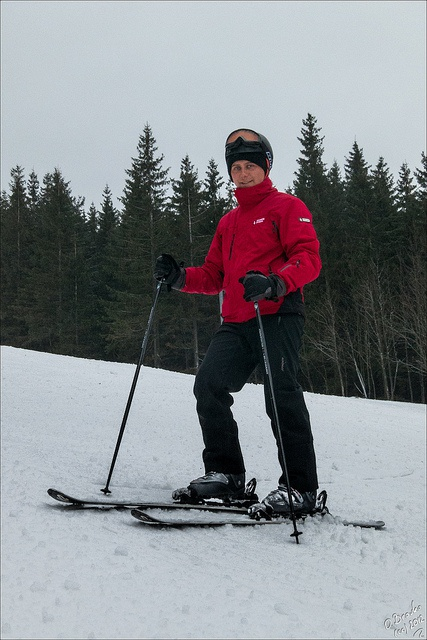Describe the objects in this image and their specific colors. I can see people in gray, black, brown, and maroon tones and skis in gray, darkgray, and black tones in this image. 